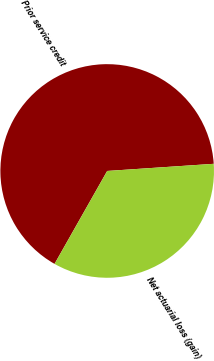<chart> <loc_0><loc_0><loc_500><loc_500><pie_chart><fcel>Prior service credit<fcel>Net actuarial loss (gain)<nl><fcel>65.73%<fcel>34.27%<nl></chart> 